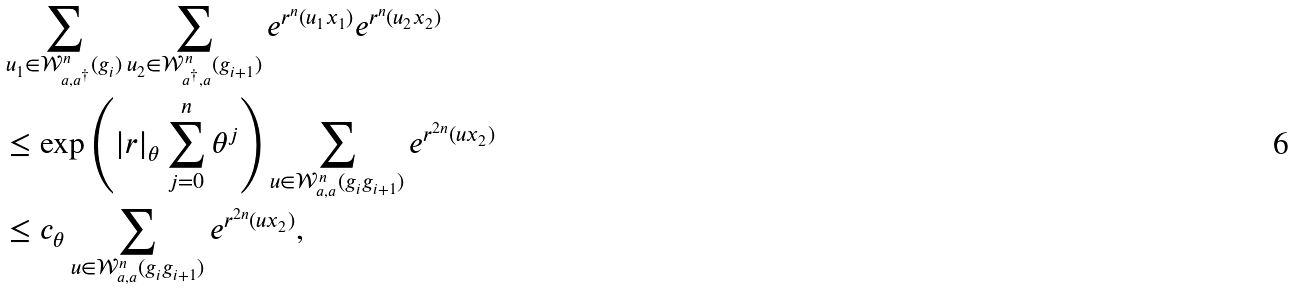<formula> <loc_0><loc_0><loc_500><loc_500>& \sum _ { u _ { 1 } \in \mathcal { W } ^ { n } _ { a , a ^ { \dag } } ( g _ { i } ) } \sum _ { u _ { 2 } \in \mathcal { W } ^ { n } _ { a ^ { \dag } , a } ( g _ { i + 1 } ) } e ^ { r ^ { n } ( u _ { 1 } x _ { 1 } ) } e ^ { r ^ { n } ( u _ { 2 } x _ { 2 } ) } \\ & \leq \exp \left ( { | r | _ { \theta } \sum _ { j = 0 } ^ { n } \theta ^ { j } } \right ) \sum _ { u \in \mathcal { W } ^ { n } _ { a , a } ( g _ { i } g _ { i + 1 } ) } e ^ { r ^ { 2 n } ( u x _ { 2 } ) } \\ & \leq c _ { \theta } \sum _ { u \in \mathcal { W } ^ { n } _ { a , a } ( g _ { i } g _ { i + 1 } ) } e ^ { r ^ { 2 n } ( u x _ { 2 } ) } ,</formula> 